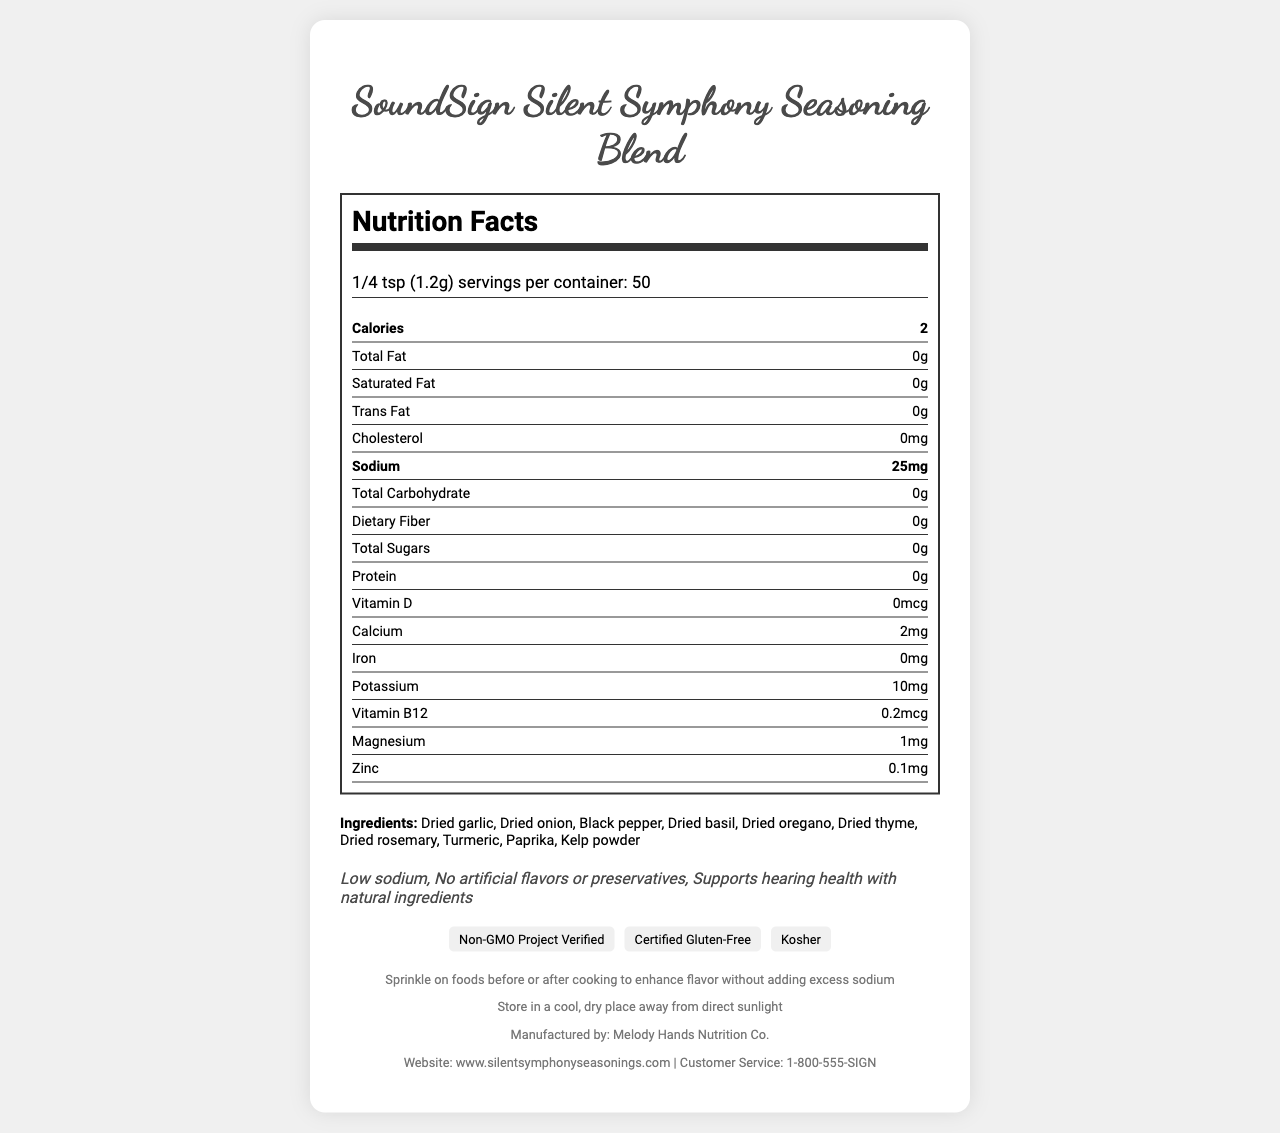what is the serving size for SoundSign Silent Symphony Seasoning Blend? The serving size is listed in the document under the header "Nutrition Facts" as "1/4 tsp (1.2g)".
Answer: 1/4 tsp (1.2g) how many servings are there per container? The document specifies that there are 50 servings per container in the "Nutrition Facts" section.
Answer: 50 what is the amount of sodium per serving? The sodium content per serving is listed as 25mg in the "Nutrition Facts" section.
Answer: 25mg name two ingredients in the seasoning blend. The ingredients section lists multiple ingredients, including "Dried garlic" and "Dried onion".
Answer: Dried garlic, Dried onion what is the website for more information about the product? The footer section includes the product website: www.silentsymphonyseasonings.com.
Answer: www.silentsymphonyseasonings.com which of the following nutrients does the seasoning contain in the highest amount per serving? A. Calcium B. Potassium C. Magnesium D. Zinc Potassium is 10mg per serving, which is higher than Calcium (2mg), Magnesium (1mg), and Zinc (0.1mg).
Answer: B which certifications does the product have? A. Non-GMO Project Verified B. Certified Gluten-Free C. Kosher D. All of the above The document lists all three certifications: Non-GMO Project Verified, Certified Gluten-Free, and Kosher.
Answer: D is this product suitable for people who have tree nut allergies? The document includes an allergen information section that states the product is produced in a facility that also processes tree nuts.
Answer: No summarize the main idea of the document. The document includes detailed information on the product's nutrition facts, ingredients, health claims, and usage/storage instructions, emphasizing its health benefits and certifications.
Answer: SoundSign Silent Symphony Seasoning Blend is a low-sodium, hearing-health focused seasoning containing natural ingredients, free from artificial flavors or preservatives, with multiple health claims and certification logos. It provides nutritional details, usage, and storage instructions. what is the manufacturing company of the product? The footer section states that the product is manufactured by Melody Hands Nutrition Co.
Answer: Melody Hands Nutrition Co. does the product contain any protein? The document shows that the protein content per serving is 0g.
Answer: No how is the product intended to support hearing health? The document states that the product supports hearing health with natural ingredients but does not specify how it achieves this.
Answer: Cannot be determined 